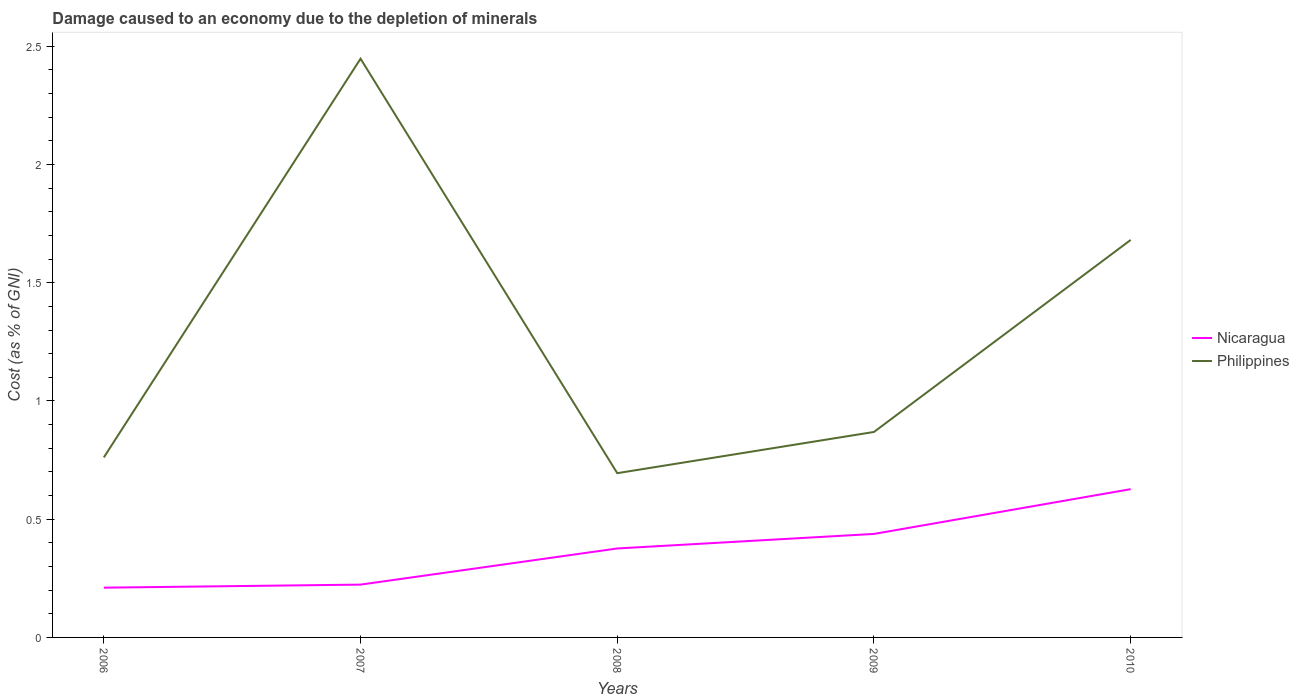How many different coloured lines are there?
Your answer should be compact. 2. Does the line corresponding to Philippines intersect with the line corresponding to Nicaragua?
Your answer should be compact. No. Is the number of lines equal to the number of legend labels?
Keep it short and to the point. Yes. Across all years, what is the maximum cost of damage caused due to the depletion of minerals in Nicaragua?
Offer a very short reply. 0.21. What is the total cost of damage caused due to the depletion of minerals in Philippines in the graph?
Your answer should be compact. -0.81. What is the difference between the highest and the second highest cost of damage caused due to the depletion of minerals in Nicaragua?
Offer a very short reply. 0.42. How many lines are there?
Provide a succinct answer. 2. How many years are there in the graph?
Provide a succinct answer. 5. Does the graph contain grids?
Your answer should be very brief. No. How many legend labels are there?
Your response must be concise. 2. What is the title of the graph?
Make the answer very short. Damage caused to an economy due to the depletion of minerals. What is the label or title of the X-axis?
Provide a short and direct response. Years. What is the label or title of the Y-axis?
Offer a terse response. Cost (as % of GNI). What is the Cost (as % of GNI) in Nicaragua in 2006?
Provide a succinct answer. 0.21. What is the Cost (as % of GNI) of Philippines in 2006?
Give a very brief answer. 0.76. What is the Cost (as % of GNI) in Nicaragua in 2007?
Provide a succinct answer. 0.22. What is the Cost (as % of GNI) of Philippines in 2007?
Make the answer very short. 2.45. What is the Cost (as % of GNI) in Nicaragua in 2008?
Provide a short and direct response. 0.38. What is the Cost (as % of GNI) in Philippines in 2008?
Keep it short and to the point. 0.69. What is the Cost (as % of GNI) of Nicaragua in 2009?
Give a very brief answer. 0.44. What is the Cost (as % of GNI) in Philippines in 2009?
Offer a very short reply. 0.87. What is the Cost (as % of GNI) of Nicaragua in 2010?
Provide a short and direct response. 0.63. What is the Cost (as % of GNI) of Philippines in 2010?
Make the answer very short. 1.68. Across all years, what is the maximum Cost (as % of GNI) of Nicaragua?
Give a very brief answer. 0.63. Across all years, what is the maximum Cost (as % of GNI) of Philippines?
Your answer should be very brief. 2.45. Across all years, what is the minimum Cost (as % of GNI) in Nicaragua?
Offer a terse response. 0.21. Across all years, what is the minimum Cost (as % of GNI) in Philippines?
Ensure brevity in your answer.  0.69. What is the total Cost (as % of GNI) of Nicaragua in the graph?
Give a very brief answer. 1.87. What is the total Cost (as % of GNI) of Philippines in the graph?
Give a very brief answer. 6.45. What is the difference between the Cost (as % of GNI) in Nicaragua in 2006 and that in 2007?
Your response must be concise. -0.01. What is the difference between the Cost (as % of GNI) in Philippines in 2006 and that in 2007?
Offer a very short reply. -1.69. What is the difference between the Cost (as % of GNI) of Nicaragua in 2006 and that in 2008?
Offer a very short reply. -0.17. What is the difference between the Cost (as % of GNI) of Philippines in 2006 and that in 2008?
Provide a short and direct response. 0.07. What is the difference between the Cost (as % of GNI) in Nicaragua in 2006 and that in 2009?
Offer a terse response. -0.23. What is the difference between the Cost (as % of GNI) of Philippines in 2006 and that in 2009?
Your response must be concise. -0.11. What is the difference between the Cost (as % of GNI) in Nicaragua in 2006 and that in 2010?
Give a very brief answer. -0.42. What is the difference between the Cost (as % of GNI) in Philippines in 2006 and that in 2010?
Give a very brief answer. -0.92. What is the difference between the Cost (as % of GNI) of Nicaragua in 2007 and that in 2008?
Make the answer very short. -0.15. What is the difference between the Cost (as % of GNI) of Philippines in 2007 and that in 2008?
Give a very brief answer. 1.75. What is the difference between the Cost (as % of GNI) in Nicaragua in 2007 and that in 2009?
Provide a short and direct response. -0.21. What is the difference between the Cost (as % of GNI) of Philippines in 2007 and that in 2009?
Provide a short and direct response. 1.58. What is the difference between the Cost (as % of GNI) in Nicaragua in 2007 and that in 2010?
Make the answer very short. -0.4. What is the difference between the Cost (as % of GNI) in Philippines in 2007 and that in 2010?
Give a very brief answer. 0.77. What is the difference between the Cost (as % of GNI) of Nicaragua in 2008 and that in 2009?
Offer a very short reply. -0.06. What is the difference between the Cost (as % of GNI) of Philippines in 2008 and that in 2009?
Give a very brief answer. -0.17. What is the difference between the Cost (as % of GNI) in Nicaragua in 2008 and that in 2010?
Provide a short and direct response. -0.25. What is the difference between the Cost (as % of GNI) of Philippines in 2008 and that in 2010?
Provide a succinct answer. -0.99. What is the difference between the Cost (as % of GNI) in Nicaragua in 2009 and that in 2010?
Make the answer very short. -0.19. What is the difference between the Cost (as % of GNI) of Philippines in 2009 and that in 2010?
Your answer should be very brief. -0.81. What is the difference between the Cost (as % of GNI) in Nicaragua in 2006 and the Cost (as % of GNI) in Philippines in 2007?
Provide a short and direct response. -2.24. What is the difference between the Cost (as % of GNI) of Nicaragua in 2006 and the Cost (as % of GNI) of Philippines in 2008?
Your answer should be very brief. -0.48. What is the difference between the Cost (as % of GNI) of Nicaragua in 2006 and the Cost (as % of GNI) of Philippines in 2009?
Provide a short and direct response. -0.66. What is the difference between the Cost (as % of GNI) in Nicaragua in 2006 and the Cost (as % of GNI) in Philippines in 2010?
Offer a terse response. -1.47. What is the difference between the Cost (as % of GNI) in Nicaragua in 2007 and the Cost (as % of GNI) in Philippines in 2008?
Provide a short and direct response. -0.47. What is the difference between the Cost (as % of GNI) of Nicaragua in 2007 and the Cost (as % of GNI) of Philippines in 2009?
Keep it short and to the point. -0.65. What is the difference between the Cost (as % of GNI) of Nicaragua in 2007 and the Cost (as % of GNI) of Philippines in 2010?
Give a very brief answer. -1.46. What is the difference between the Cost (as % of GNI) of Nicaragua in 2008 and the Cost (as % of GNI) of Philippines in 2009?
Ensure brevity in your answer.  -0.49. What is the difference between the Cost (as % of GNI) in Nicaragua in 2008 and the Cost (as % of GNI) in Philippines in 2010?
Your response must be concise. -1.3. What is the difference between the Cost (as % of GNI) of Nicaragua in 2009 and the Cost (as % of GNI) of Philippines in 2010?
Give a very brief answer. -1.24. What is the average Cost (as % of GNI) of Nicaragua per year?
Offer a terse response. 0.37. What is the average Cost (as % of GNI) in Philippines per year?
Your answer should be very brief. 1.29. In the year 2006, what is the difference between the Cost (as % of GNI) in Nicaragua and Cost (as % of GNI) in Philippines?
Offer a terse response. -0.55. In the year 2007, what is the difference between the Cost (as % of GNI) of Nicaragua and Cost (as % of GNI) of Philippines?
Keep it short and to the point. -2.22. In the year 2008, what is the difference between the Cost (as % of GNI) in Nicaragua and Cost (as % of GNI) in Philippines?
Offer a very short reply. -0.32. In the year 2009, what is the difference between the Cost (as % of GNI) in Nicaragua and Cost (as % of GNI) in Philippines?
Offer a terse response. -0.43. In the year 2010, what is the difference between the Cost (as % of GNI) of Nicaragua and Cost (as % of GNI) of Philippines?
Provide a short and direct response. -1.05. What is the ratio of the Cost (as % of GNI) of Nicaragua in 2006 to that in 2007?
Offer a very short reply. 0.94. What is the ratio of the Cost (as % of GNI) in Philippines in 2006 to that in 2007?
Give a very brief answer. 0.31. What is the ratio of the Cost (as % of GNI) of Nicaragua in 2006 to that in 2008?
Keep it short and to the point. 0.56. What is the ratio of the Cost (as % of GNI) in Philippines in 2006 to that in 2008?
Offer a very short reply. 1.1. What is the ratio of the Cost (as % of GNI) in Nicaragua in 2006 to that in 2009?
Make the answer very short. 0.48. What is the ratio of the Cost (as % of GNI) in Philippines in 2006 to that in 2009?
Give a very brief answer. 0.88. What is the ratio of the Cost (as % of GNI) of Nicaragua in 2006 to that in 2010?
Keep it short and to the point. 0.34. What is the ratio of the Cost (as % of GNI) of Philippines in 2006 to that in 2010?
Offer a terse response. 0.45. What is the ratio of the Cost (as % of GNI) in Nicaragua in 2007 to that in 2008?
Make the answer very short. 0.59. What is the ratio of the Cost (as % of GNI) of Philippines in 2007 to that in 2008?
Your answer should be very brief. 3.52. What is the ratio of the Cost (as % of GNI) of Nicaragua in 2007 to that in 2009?
Give a very brief answer. 0.51. What is the ratio of the Cost (as % of GNI) in Philippines in 2007 to that in 2009?
Your answer should be very brief. 2.82. What is the ratio of the Cost (as % of GNI) in Nicaragua in 2007 to that in 2010?
Your answer should be compact. 0.36. What is the ratio of the Cost (as % of GNI) of Philippines in 2007 to that in 2010?
Your answer should be very brief. 1.46. What is the ratio of the Cost (as % of GNI) of Nicaragua in 2008 to that in 2009?
Provide a short and direct response. 0.86. What is the ratio of the Cost (as % of GNI) of Philippines in 2008 to that in 2009?
Your response must be concise. 0.8. What is the ratio of the Cost (as % of GNI) of Nicaragua in 2008 to that in 2010?
Your answer should be compact. 0.6. What is the ratio of the Cost (as % of GNI) of Philippines in 2008 to that in 2010?
Your answer should be compact. 0.41. What is the ratio of the Cost (as % of GNI) in Nicaragua in 2009 to that in 2010?
Offer a terse response. 0.7. What is the ratio of the Cost (as % of GNI) in Philippines in 2009 to that in 2010?
Offer a terse response. 0.52. What is the difference between the highest and the second highest Cost (as % of GNI) in Nicaragua?
Your response must be concise. 0.19. What is the difference between the highest and the second highest Cost (as % of GNI) in Philippines?
Provide a short and direct response. 0.77. What is the difference between the highest and the lowest Cost (as % of GNI) of Nicaragua?
Your response must be concise. 0.42. What is the difference between the highest and the lowest Cost (as % of GNI) in Philippines?
Your answer should be compact. 1.75. 